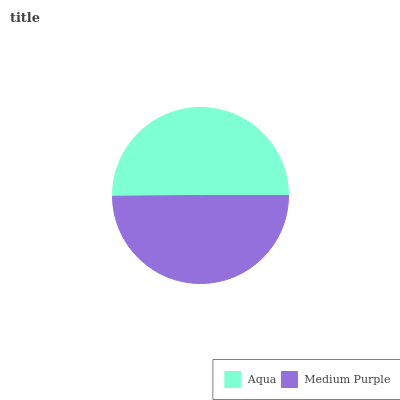Is Medium Purple the minimum?
Answer yes or no. Yes. Is Aqua the maximum?
Answer yes or no. Yes. Is Medium Purple the maximum?
Answer yes or no. No. Is Aqua greater than Medium Purple?
Answer yes or no. Yes. Is Medium Purple less than Aqua?
Answer yes or no. Yes. Is Medium Purple greater than Aqua?
Answer yes or no. No. Is Aqua less than Medium Purple?
Answer yes or no. No. Is Aqua the high median?
Answer yes or no. Yes. Is Medium Purple the low median?
Answer yes or no. Yes. Is Medium Purple the high median?
Answer yes or no. No. Is Aqua the low median?
Answer yes or no. No. 